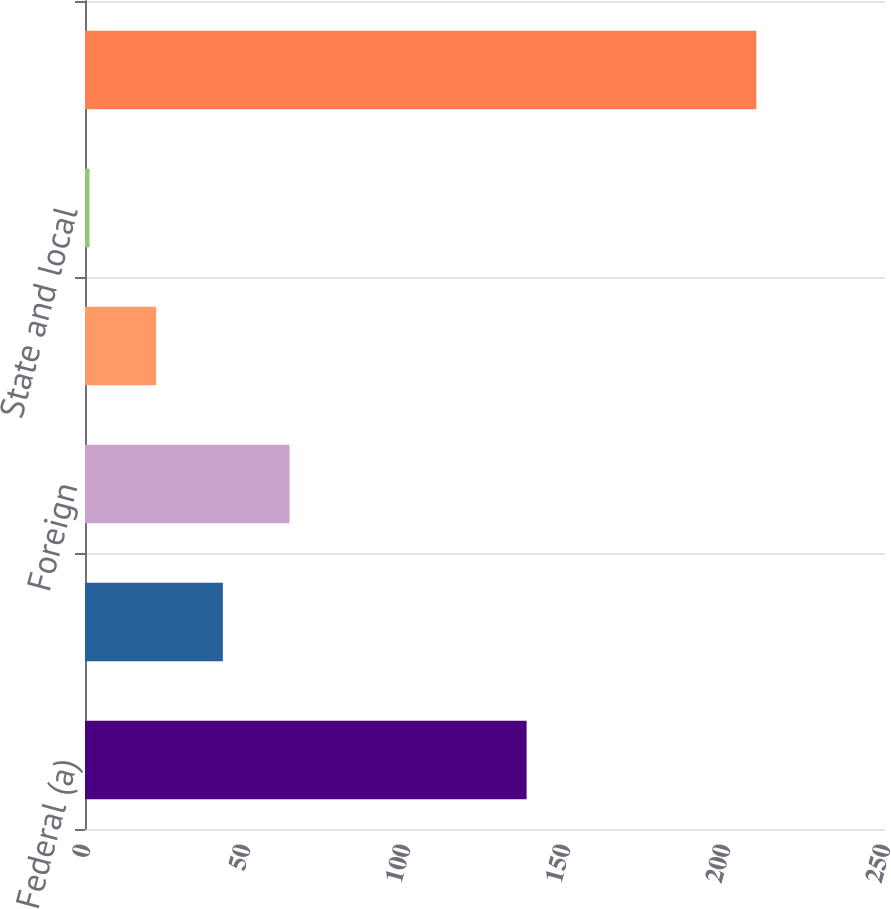<chart> <loc_0><loc_0><loc_500><loc_500><bar_chart><fcel>Federal (a)<fcel>State and local (a)<fcel>Foreign<fcel>Federal<fcel>State and local<fcel>Total provision for income<nl><fcel>138<fcel>43.08<fcel>63.92<fcel>22.24<fcel>1.4<fcel>209.8<nl></chart> 